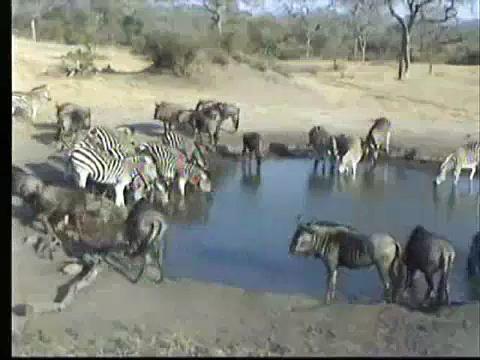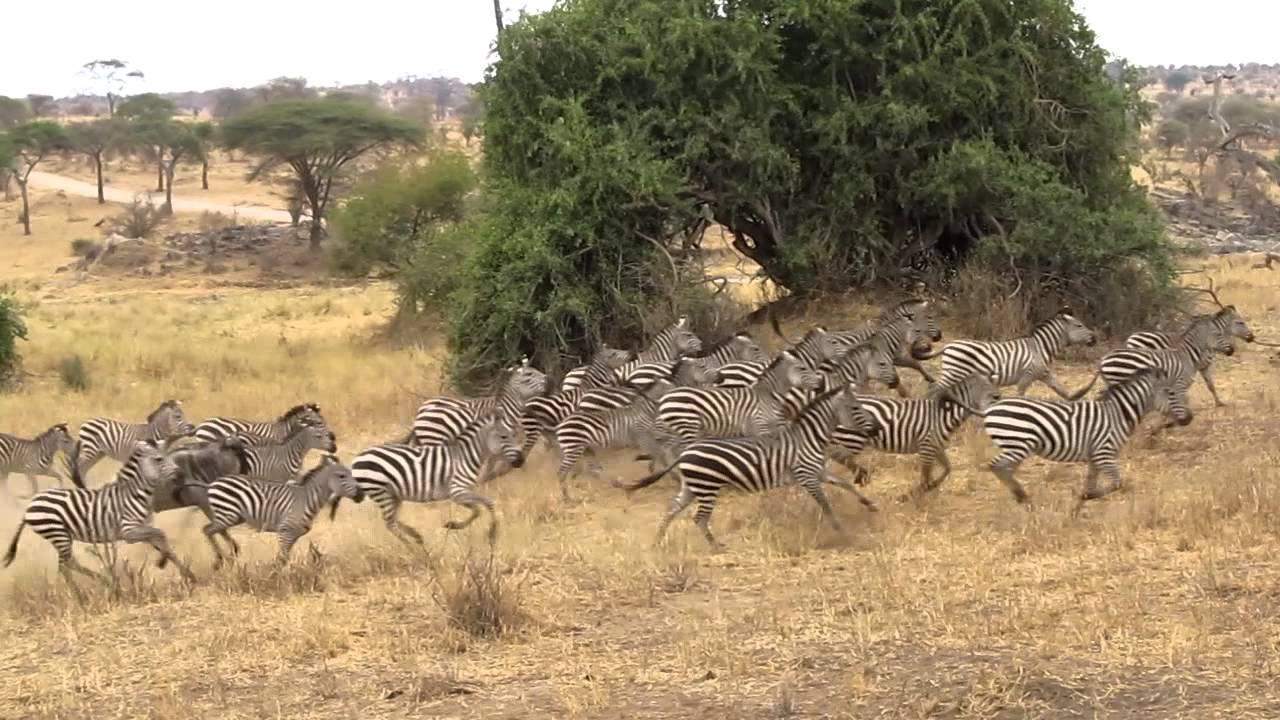The first image is the image on the left, the second image is the image on the right. Analyze the images presented: Is the assertion "In one image, only zebras and no other species can be seen." valid? Answer yes or no. Yes. The first image is the image on the left, the second image is the image on the right. For the images shown, is this caption "Multiple zebras and gnus, including multiple rear-facing animals, are at a watering hole in one image." true? Answer yes or no. Yes. 